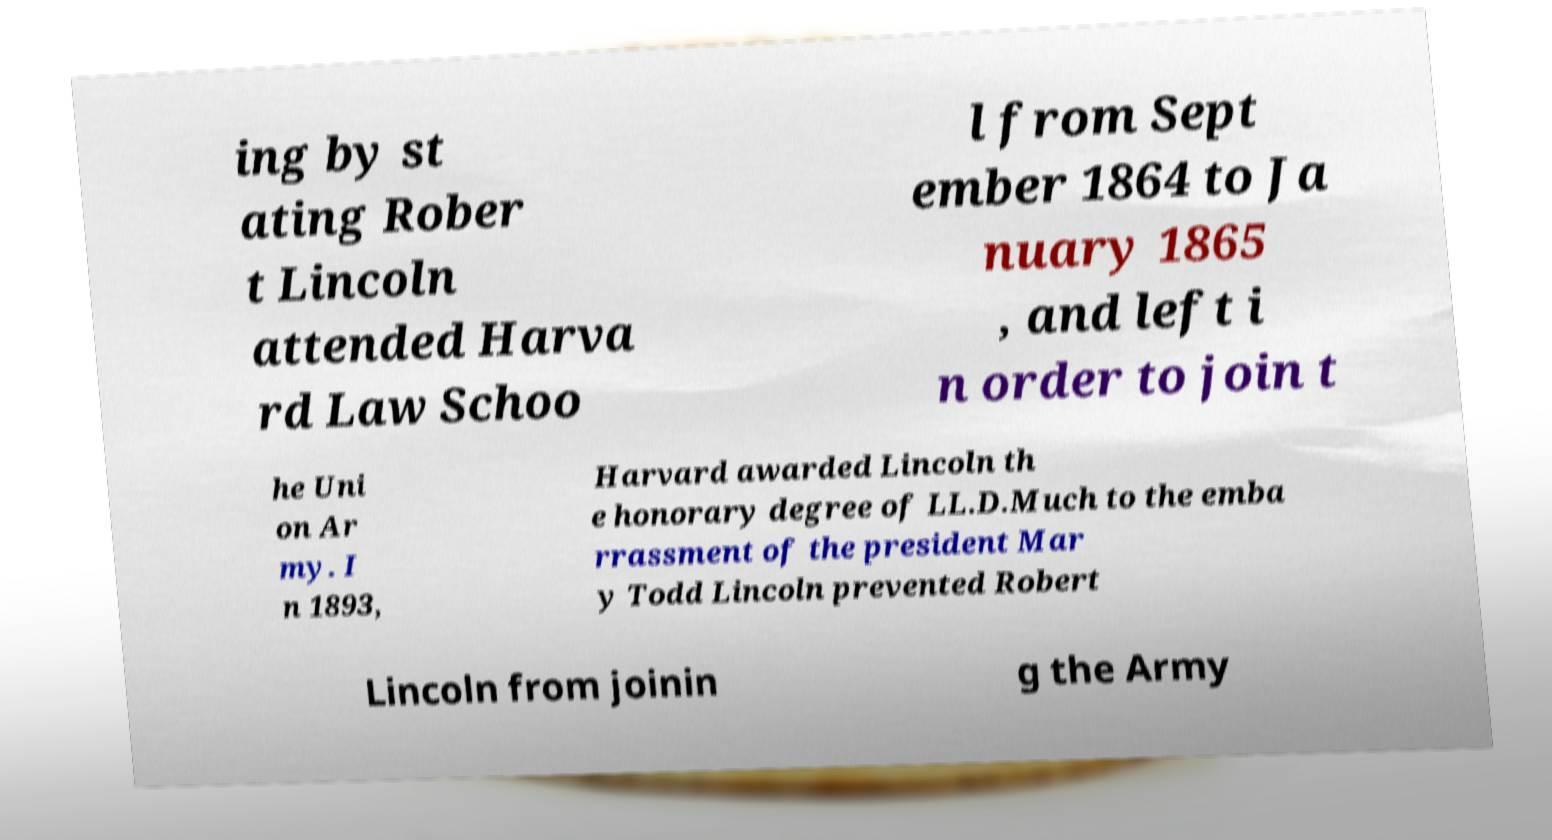Could you extract and type out the text from this image? ing by st ating Rober t Lincoln attended Harva rd Law Schoo l from Sept ember 1864 to Ja nuary 1865 , and left i n order to join t he Uni on Ar my. I n 1893, Harvard awarded Lincoln th e honorary degree of LL.D.Much to the emba rrassment of the president Mar y Todd Lincoln prevented Robert Lincoln from joinin g the Army 